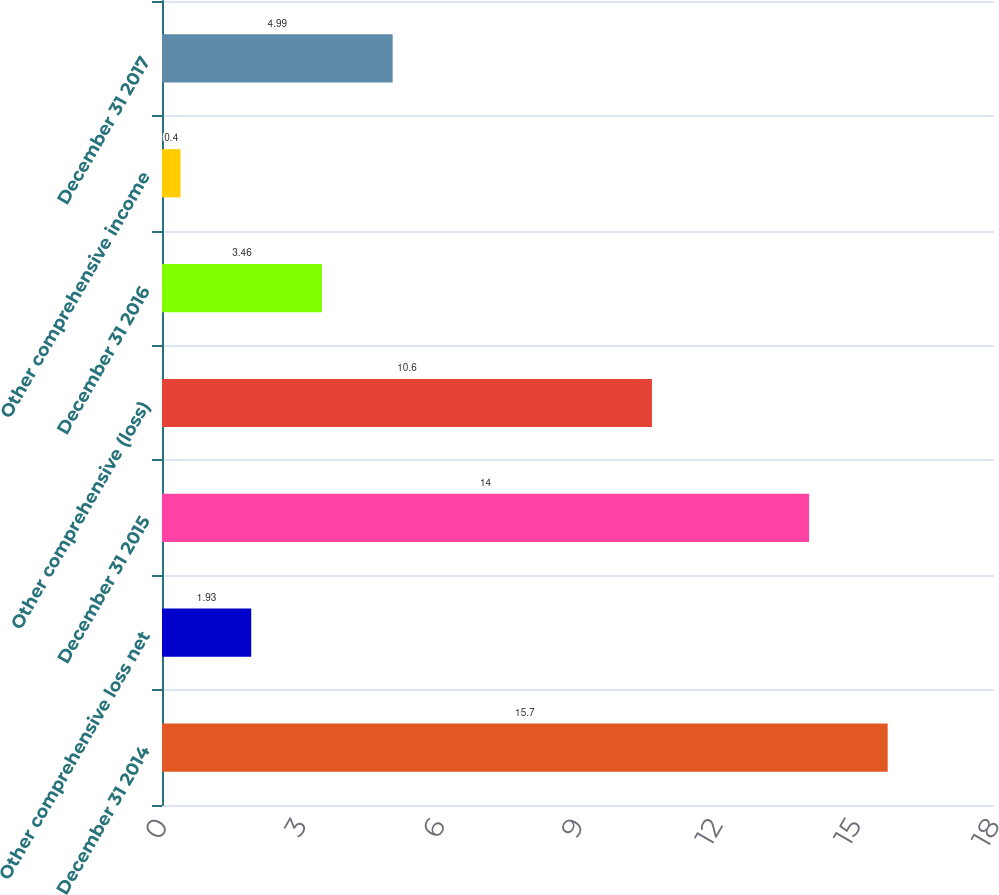<chart> <loc_0><loc_0><loc_500><loc_500><bar_chart><fcel>December 31 2014<fcel>Other comprehensive loss net<fcel>December 31 2015<fcel>Other comprehensive (loss)<fcel>December 31 2016<fcel>Other comprehensive income<fcel>December 31 2017<nl><fcel>15.7<fcel>1.93<fcel>14<fcel>10.6<fcel>3.46<fcel>0.4<fcel>4.99<nl></chart> 